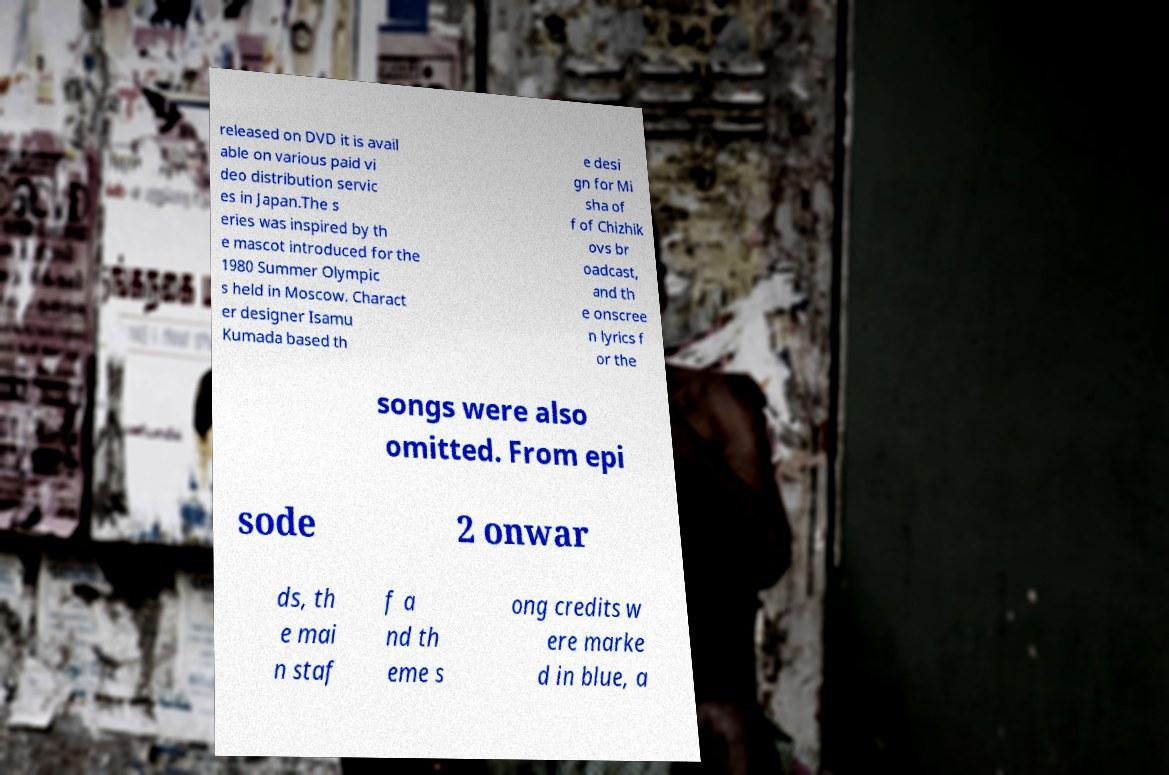There's text embedded in this image that I need extracted. Can you transcribe it verbatim? released on DVD it is avail able on various paid vi deo distribution servic es in Japan.The s eries was inspired by th e mascot introduced for the 1980 Summer Olympic s held in Moscow. Charact er designer Isamu Kumada based th e desi gn for Mi sha of f of Chizhik ovs br oadcast, and th e onscree n lyrics f or the songs were also omitted. From epi sode 2 onwar ds, th e mai n staf f a nd th eme s ong credits w ere marke d in blue, a 